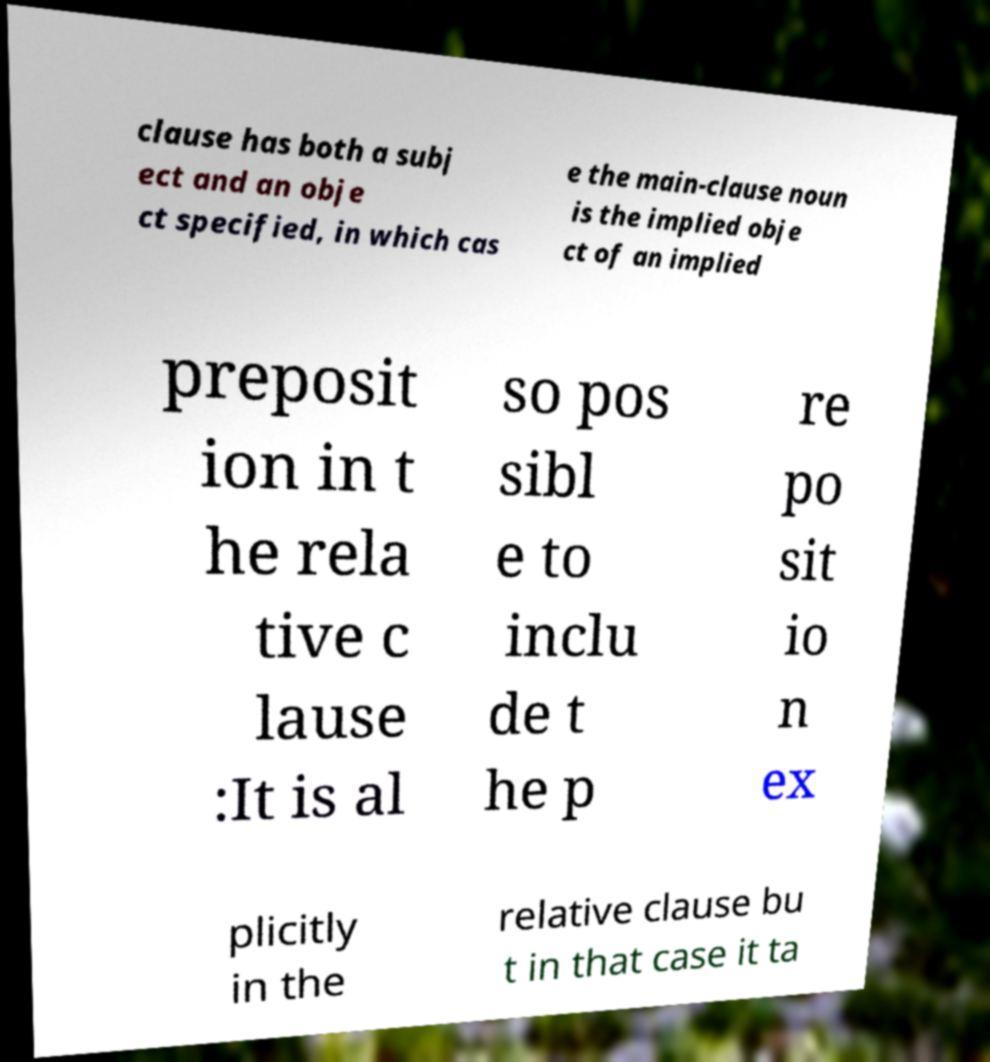There's text embedded in this image that I need extracted. Can you transcribe it verbatim? clause has both a subj ect and an obje ct specified, in which cas e the main-clause noun is the implied obje ct of an implied preposit ion in t he rela tive c lause :It is al so pos sibl e to inclu de t he p re po sit io n ex plicitly in the relative clause bu t in that case it ta 